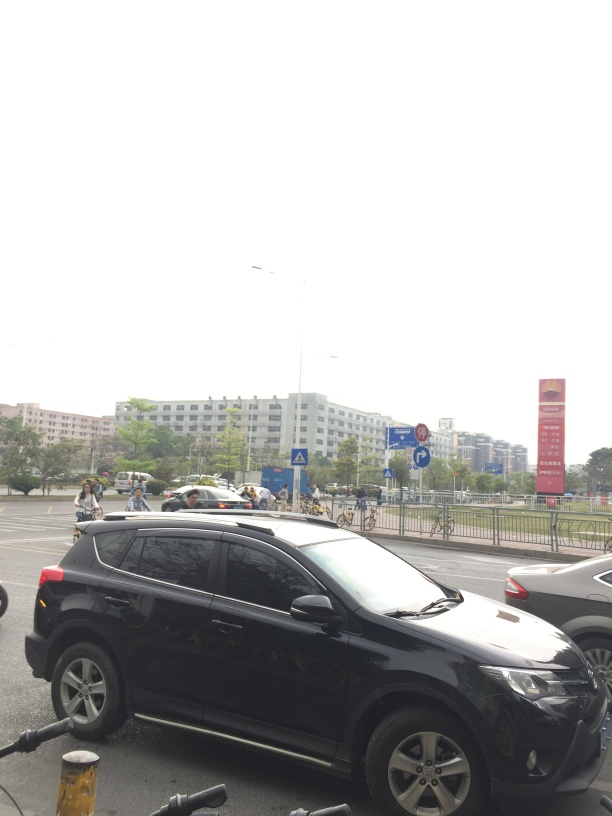Can you describe the setting of this image? The image depicts an urban scene, likely taken from a sidewalk. A black car is prominently in the foreground with bicycles parked alongside. In the background, there are more vehicles, a pedestrian crossing, and a pedestrian area, suggesting a busy city environment. Some buildings and trees can also be seen, presenting a typical street view. 